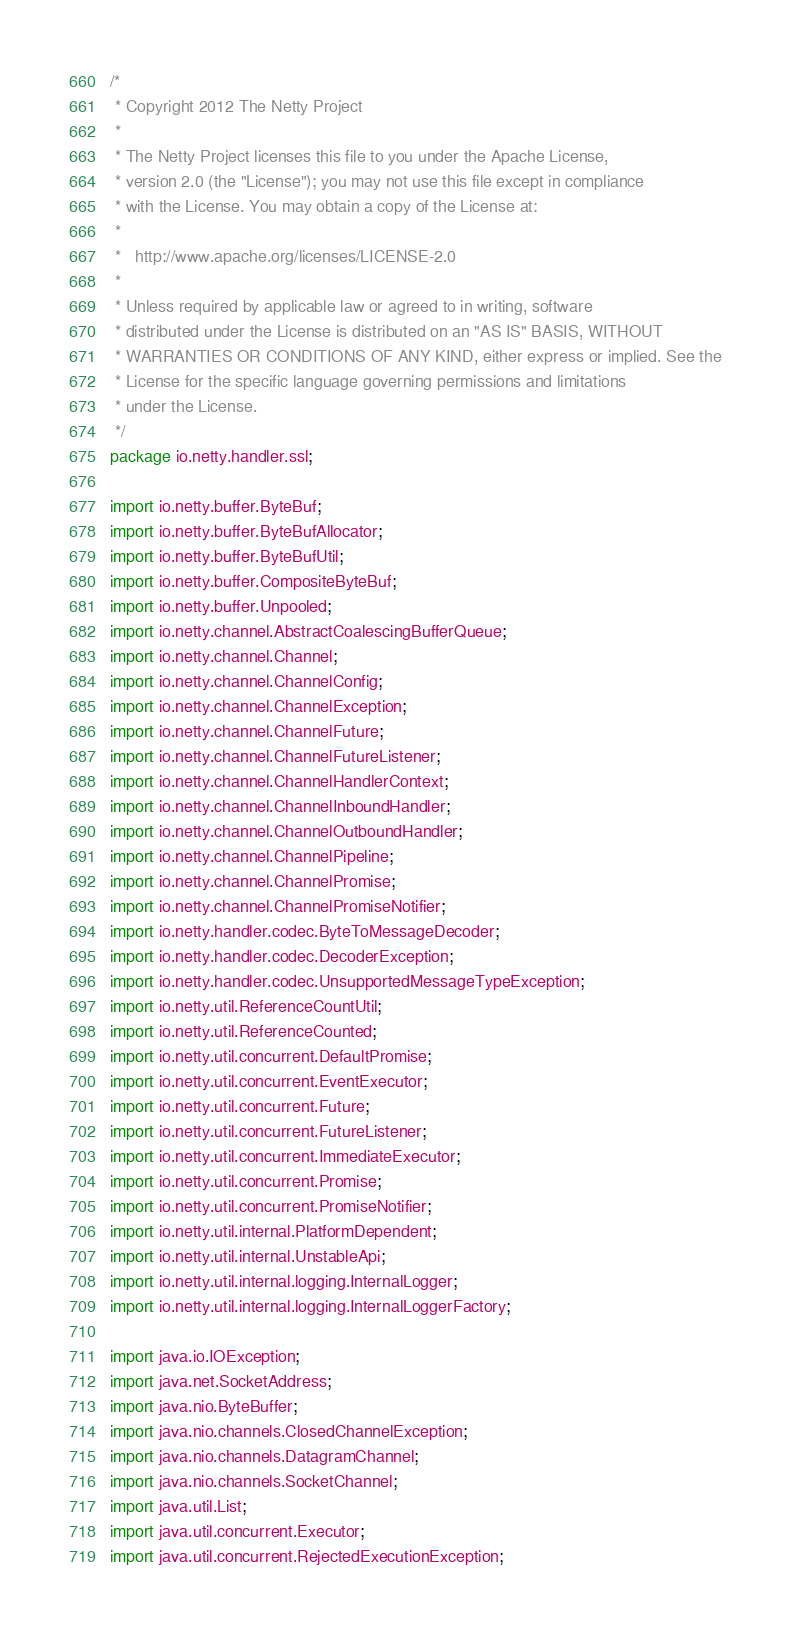<code> <loc_0><loc_0><loc_500><loc_500><_Java_>/*
 * Copyright 2012 The Netty Project
 *
 * The Netty Project licenses this file to you under the Apache License,
 * version 2.0 (the "License"); you may not use this file except in compliance
 * with the License. You may obtain a copy of the License at:
 *
 *   http://www.apache.org/licenses/LICENSE-2.0
 *
 * Unless required by applicable law or agreed to in writing, software
 * distributed under the License is distributed on an "AS IS" BASIS, WITHOUT
 * WARRANTIES OR CONDITIONS OF ANY KIND, either express or implied. See the
 * License for the specific language governing permissions and limitations
 * under the License.
 */
package io.netty.handler.ssl;

import io.netty.buffer.ByteBuf;
import io.netty.buffer.ByteBufAllocator;
import io.netty.buffer.ByteBufUtil;
import io.netty.buffer.CompositeByteBuf;
import io.netty.buffer.Unpooled;
import io.netty.channel.AbstractCoalescingBufferQueue;
import io.netty.channel.Channel;
import io.netty.channel.ChannelConfig;
import io.netty.channel.ChannelException;
import io.netty.channel.ChannelFuture;
import io.netty.channel.ChannelFutureListener;
import io.netty.channel.ChannelHandlerContext;
import io.netty.channel.ChannelInboundHandler;
import io.netty.channel.ChannelOutboundHandler;
import io.netty.channel.ChannelPipeline;
import io.netty.channel.ChannelPromise;
import io.netty.channel.ChannelPromiseNotifier;
import io.netty.handler.codec.ByteToMessageDecoder;
import io.netty.handler.codec.DecoderException;
import io.netty.handler.codec.UnsupportedMessageTypeException;
import io.netty.util.ReferenceCountUtil;
import io.netty.util.ReferenceCounted;
import io.netty.util.concurrent.DefaultPromise;
import io.netty.util.concurrent.EventExecutor;
import io.netty.util.concurrent.Future;
import io.netty.util.concurrent.FutureListener;
import io.netty.util.concurrent.ImmediateExecutor;
import io.netty.util.concurrent.Promise;
import io.netty.util.concurrent.PromiseNotifier;
import io.netty.util.internal.PlatformDependent;
import io.netty.util.internal.UnstableApi;
import io.netty.util.internal.logging.InternalLogger;
import io.netty.util.internal.logging.InternalLoggerFactory;

import java.io.IOException;
import java.net.SocketAddress;
import java.nio.ByteBuffer;
import java.nio.channels.ClosedChannelException;
import java.nio.channels.DatagramChannel;
import java.nio.channels.SocketChannel;
import java.util.List;
import java.util.concurrent.Executor;
import java.util.concurrent.RejectedExecutionException;</code> 